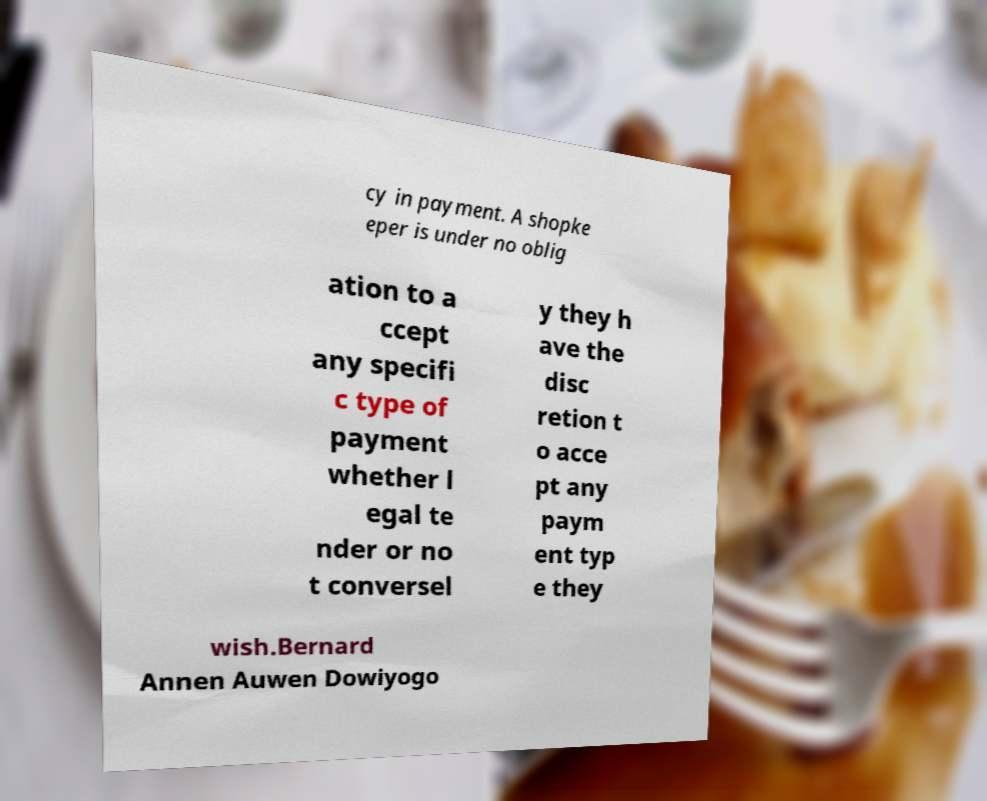Could you extract and type out the text from this image? cy in payment. A shopke eper is under no oblig ation to a ccept any specifi c type of payment whether l egal te nder or no t conversel y they h ave the disc retion t o acce pt any paym ent typ e they wish.Bernard Annen Auwen Dowiyogo 